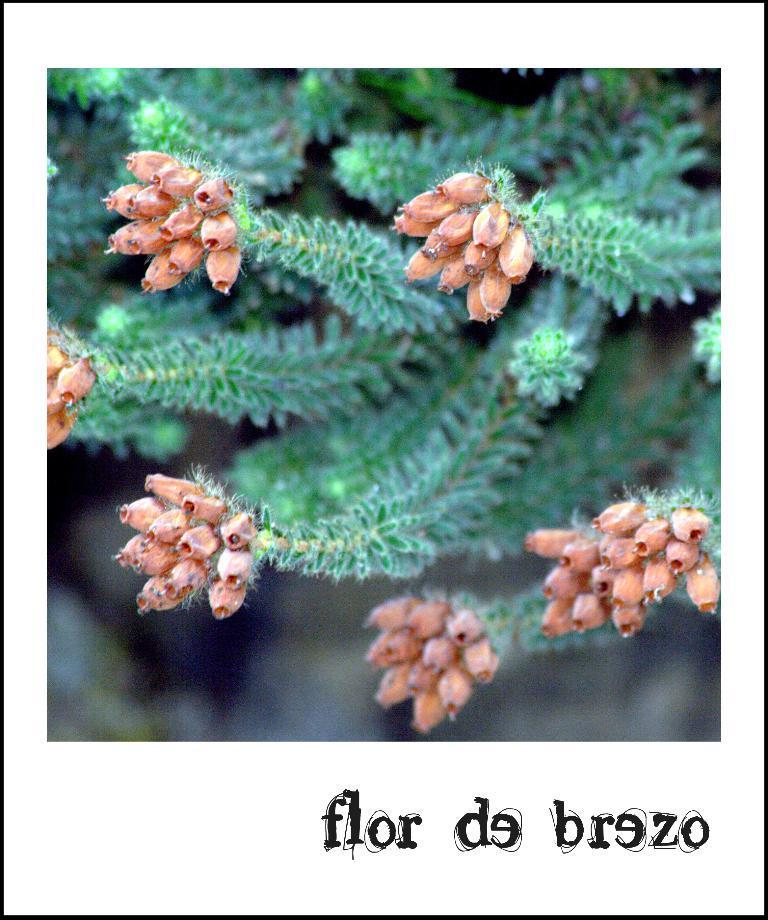Can you describe this image briefly? In the picture we can see some plants and bottom of the picture we can see some words written. 